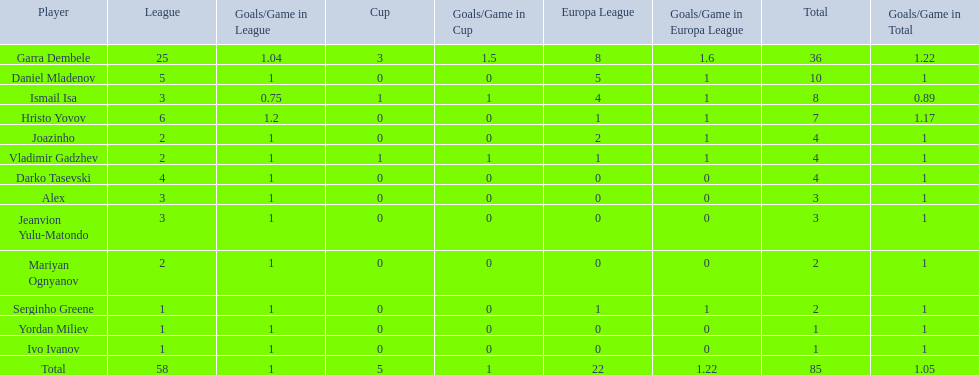Which athletes have a minimum of 4 in the europa league? Garra Dembele, Daniel Mladenov, Ismail Isa. 